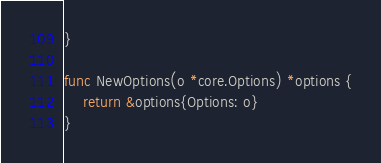Convert code to text. <code><loc_0><loc_0><loc_500><loc_500><_Go_>}

func NewOptions(o *core.Options) *options {
	return &options{Options: o}
}
</code> 